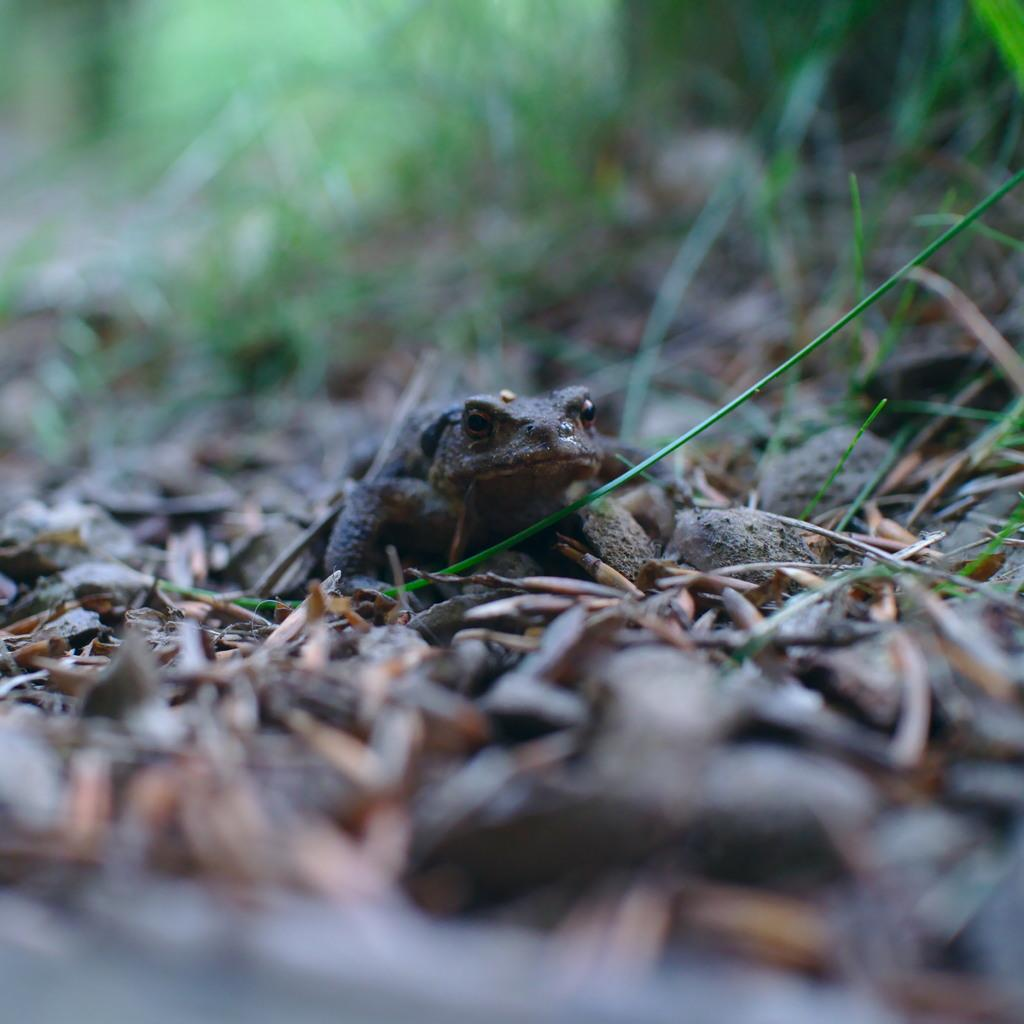What animal is present in the image? There is a frog in the image. Where is the frog located? The frog is on the ground. Can you describe the background of the image? The background of the image is blurry. What type of spy equipment can be seen in the image? There is no spy equipment present in the image; it features a frog on the ground with a blurry background. Does the frog express any feelings of hate in the image? The image does not convey any emotions, including hate, from the frog. 